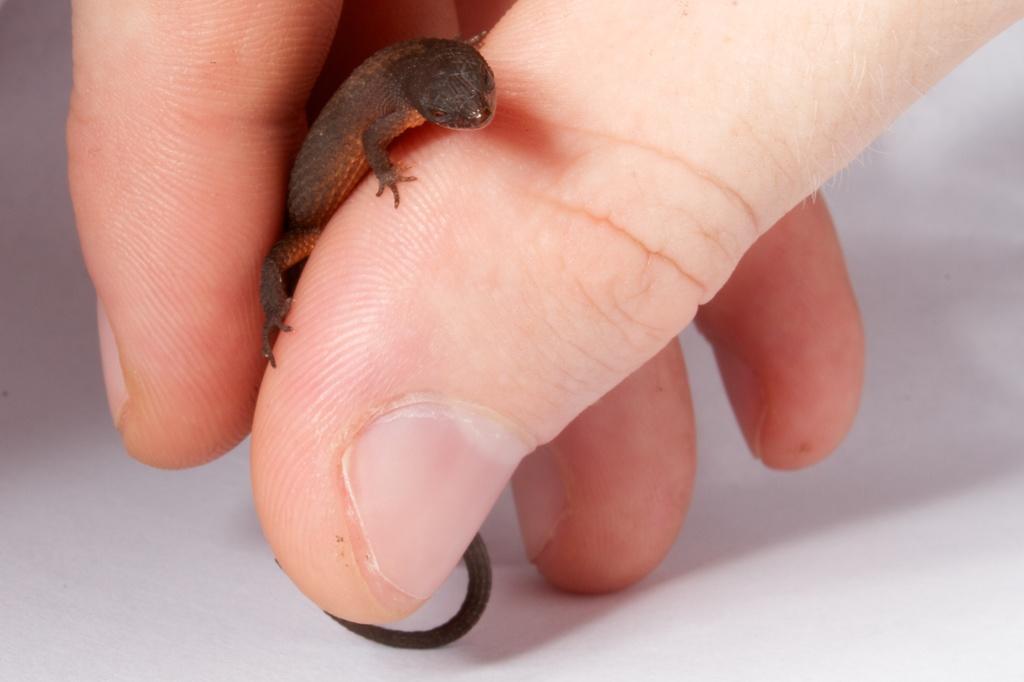Describe this image in one or two sentences. In the center of the image we can see one human hand holding one reptile, which is in brown color. And we can see the white color background. 